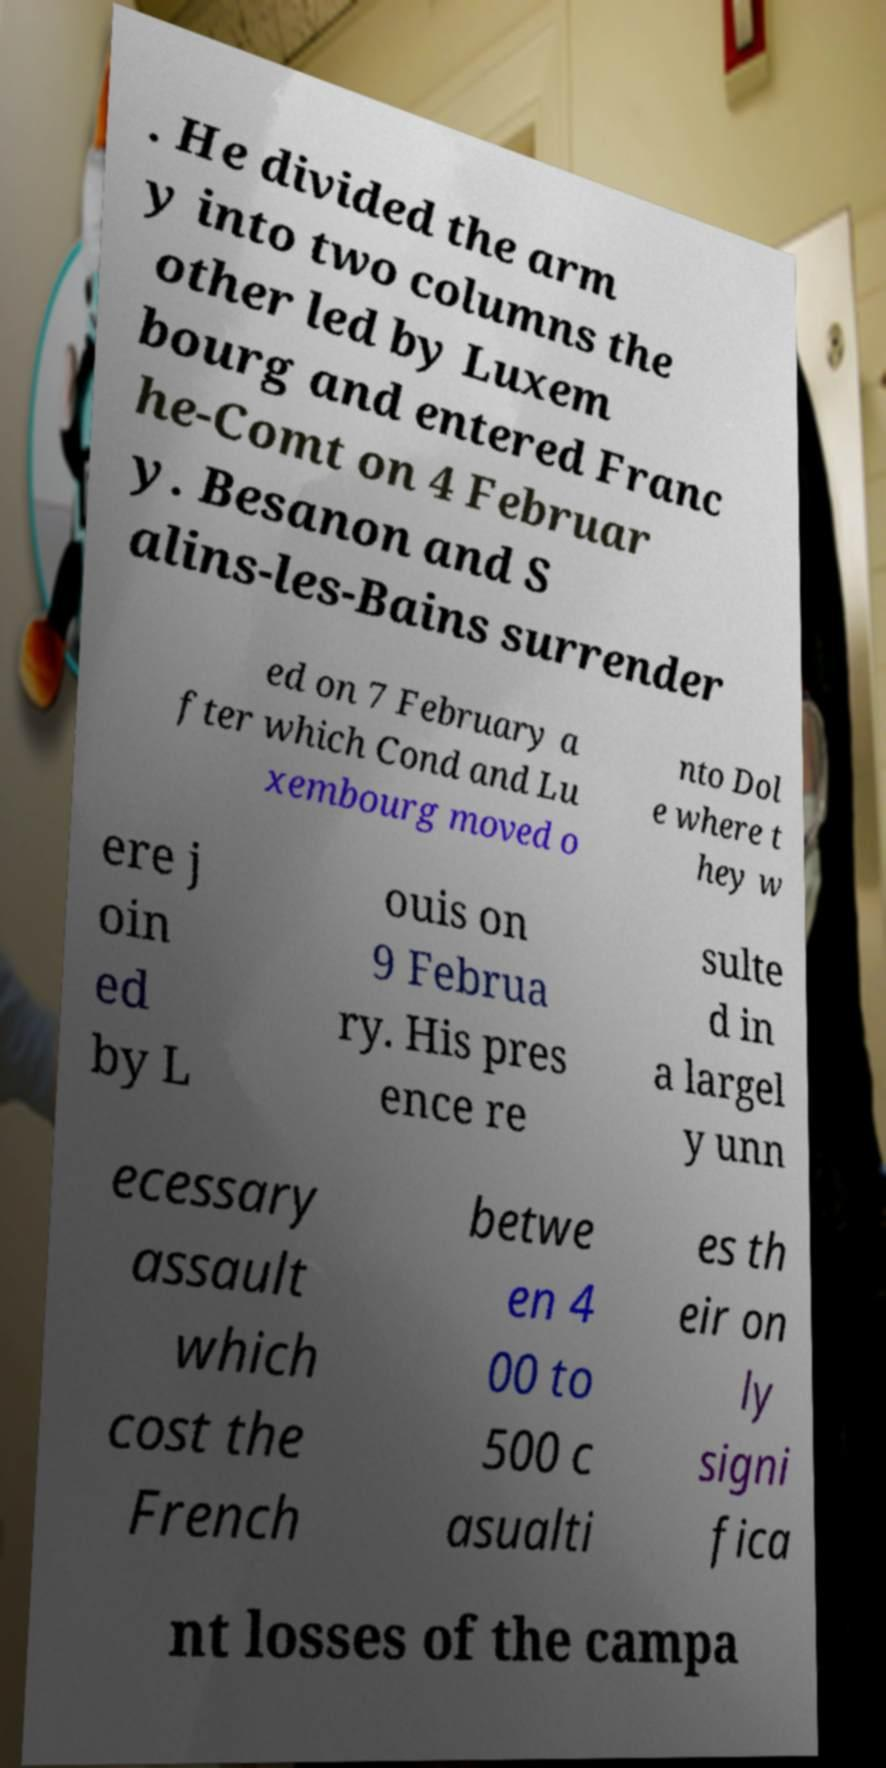I need the written content from this picture converted into text. Can you do that? . He divided the arm y into two columns the other led by Luxem bourg and entered Franc he-Comt on 4 Februar y. Besanon and S alins-les-Bains surrender ed on 7 February a fter which Cond and Lu xembourg moved o nto Dol e where t hey w ere j oin ed by L ouis on 9 Februa ry. His pres ence re sulte d in a largel y unn ecessary assault which cost the French betwe en 4 00 to 500 c asualti es th eir on ly signi fica nt losses of the campa 